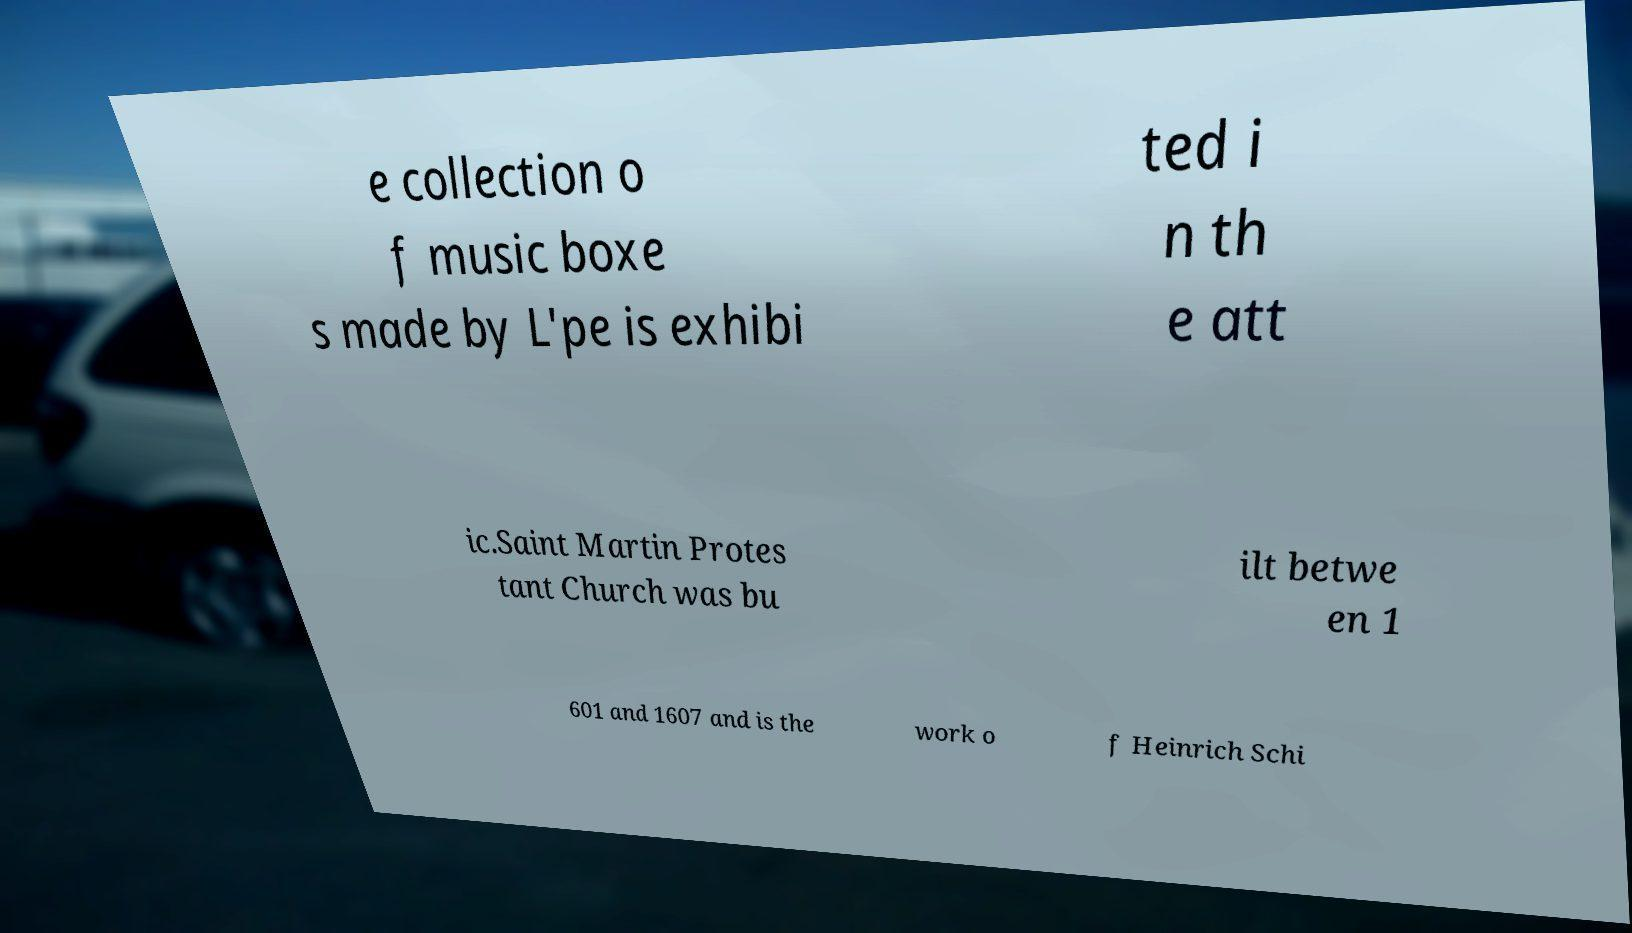Could you assist in decoding the text presented in this image and type it out clearly? e collection o f music boxe s made by L'pe is exhibi ted i n th e att ic.Saint Martin Protes tant Church was bu ilt betwe en 1 601 and 1607 and is the work o f Heinrich Schi 